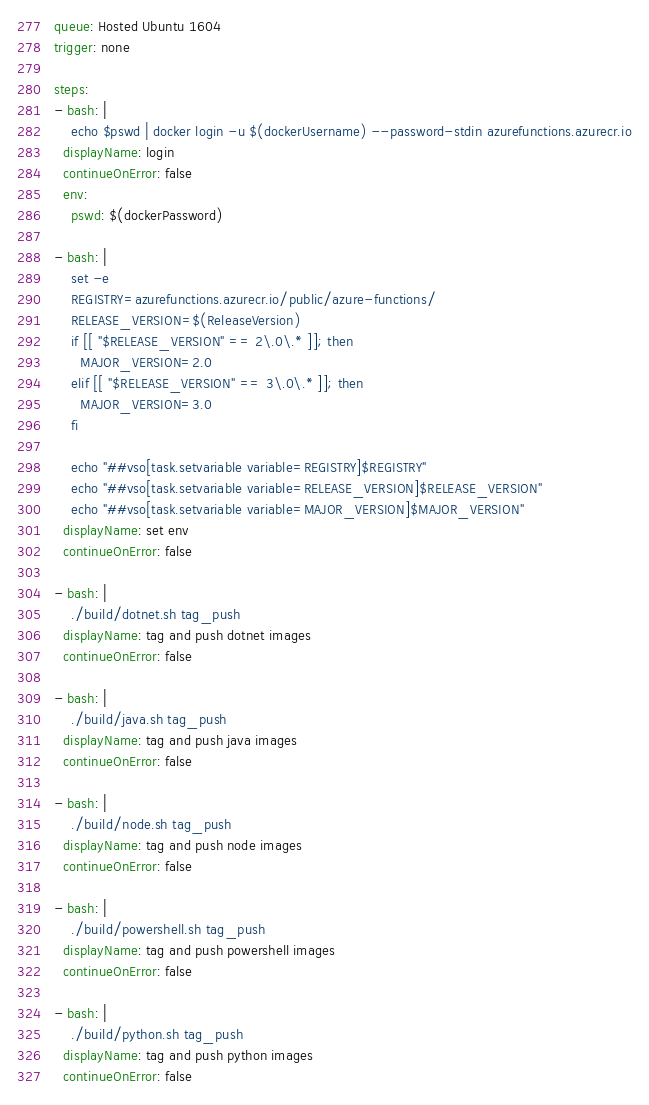Convert code to text. <code><loc_0><loc_0><loc_500><loc_500><_YAML_>queue: Hosted Ubuntu 1604
trigger: none

steps:
- bash: |
    echo $pswd | docker login -u $(dockerUsername) --password-stdin azurefunctions.azurecr.io
  displayName: login
  continueOnError: false
  env:
    pswd: $(dockerPassword)

- bash: |
    set -e
    REGISTRY=azurefunctions.azurecr.io/public/azure-functions/
    RELEASE_VERSION=$(ReleaseVersion)
    if [[ "$RELEASE_VERSION" == 2\.0\.* ]]; then
      MAJOR_VERSION=2.0
    elif [[ "$RELEASE_VERSION" == 3\.0\.* ]]; then
      MAJOR_VERSION=3.0
    fi

    echo "##vso[task.setvariable variable=REGISTRY]$REGISTRY"
    echo "##vso[task.setvariable variable=RELEASE_VERSION]$RELEASE_VERSION"
    echo "##vso[task.setvariable variable=MAJOR_VERSION]$MAJOR_VERSION"
  displayName: set env
  continueOnError: false

- bash: |
    ./build/dotnet.sh tag_push
  displayName: tag and push dotnet images
  continueOnError: false

- bash: |
    ./build/java.sh tag_push
  displayName: tag and push java images
  continueOnError: false

- bash: |
    ./build/node.sh tag_push
  displayName: tag and push node images
  continueOnError: false

- bash: |
    ./build/powershell.sh tag_push
  displayName: tag and push powershell images
  continueOnError: false

- bash: |
    ./build/python.sh tag_push
  displayName: tag and push python images
  continueOnError: false
</code> 